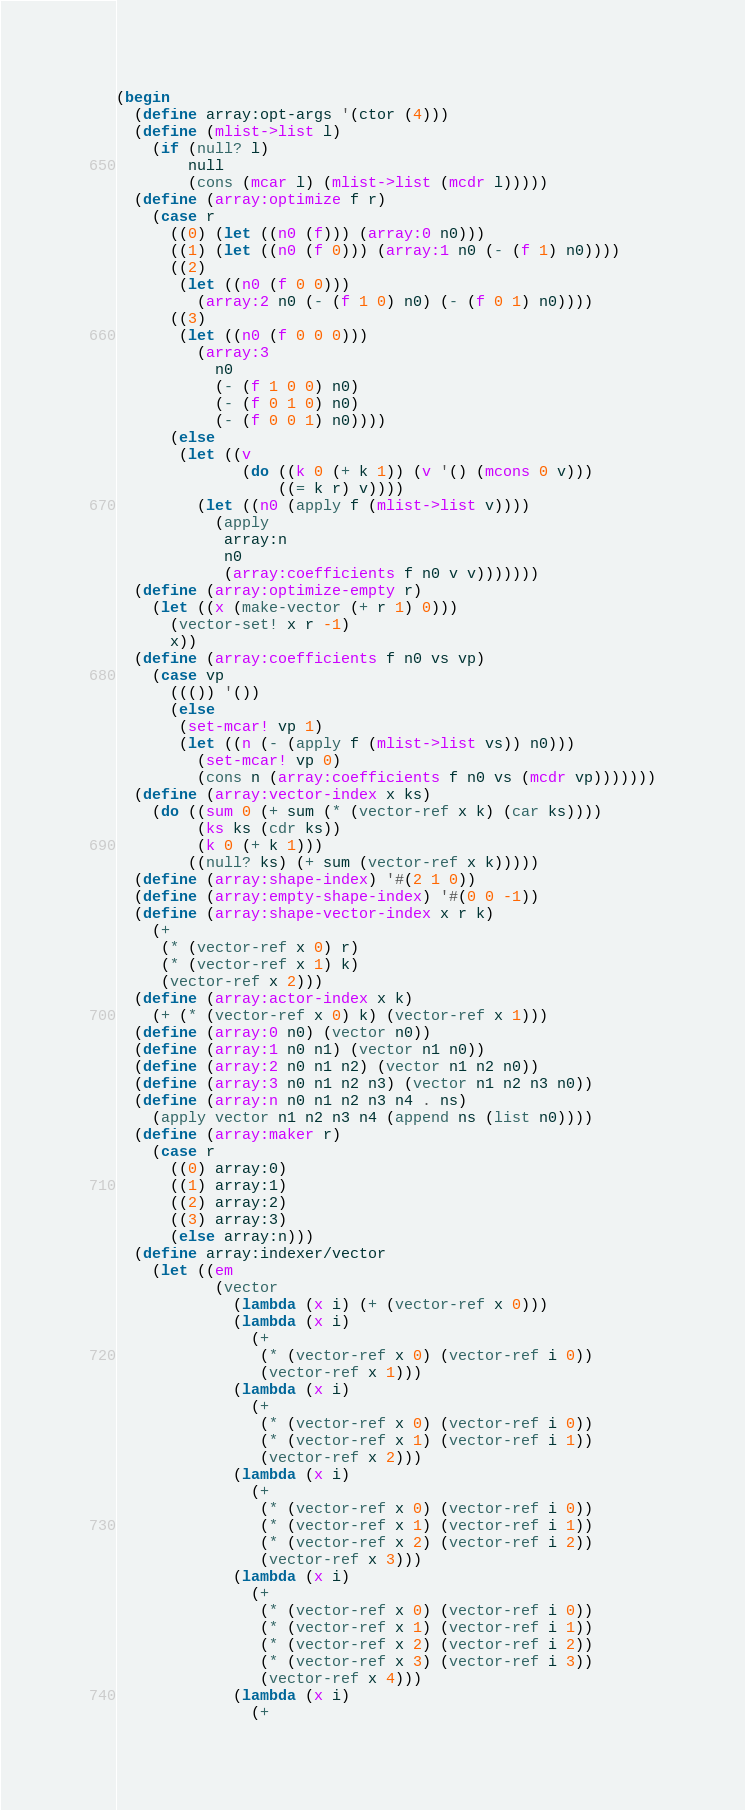<code> <loc_0><loc_0><loc_500><loc_500><_Scheme_>(begin
  (define array:opt-args '(ctor (4)))
  (define (mlist->list l)
    (if (null? l)
        null
        (cons (mcar l) (mlist->list (mcdr l)))))
  (define (array:optimize f r)
    (case r
      ((0) (let ((n0 (f))) (array:0 n0)))
      ((1) (let ((n0 (f 0))) (array:1 n0 (- (f 1) n0))))
      ((2)
       (let ((n0 (f 0 0)))
         (array:2 n0 (- (f 1 0) n0) (- (f 0 1) n0))))
      ((3)
       (let ((n0 (f 0 0 0)))
         (array:3
           n0
           (- (f 1 0 0) n0)
           (- (f 0 1 0) n0)
           (- (f 0 0 1) n0))))
      (else
       (let ((v
              (do ((k 0 (+ k 1)) (v '() (mcons 0 v)))
                  ((= k r) v))))
         (let ((n0 (apply f (mlist->list v))))
           (apply
            array:n
            n0
            (array:coefficients f n0 v v)))))))
  (define (array:optimize-empty r)
    (let ((x (make-vector (+ r 1) 0)))
      (vector-set! x r -1)
      x))
  (define (array:coefficients f n0 vs vp)
    (case vp
      ((()) '())
      (else
       (set-mcar! vp 1)
       (let ((n (- (apply f (mlist->list vs)) n0)))
         (set-mcar! vp 0)
         (cons n (array:coefficients f n0 vs (mcdr vp)))))))
  (define (array:vector-index x ks)
    (do ((sum 0 (+ sum (* (vector-ref x k) (car ks))))
         (ks ks (cdr ks))
         (k 0 (+ k 1)))
        ((null? ks) (+ sum (vector-ref x k)))))
  (define (array:shape-index) '#(2 1 0))
  (define (array:empty-shape-index) '#(0 0 -1))
  (define (array:shape-vector-index x r k)
    (+
     (* (vector-ref x 0) r)
     (* (vector-ref x 1) k)
     (vector-ref x 2)))
  (define (array:actor-index x k)
    (+ (* (vector-ref x 0) k) (vector-ref x 1)))
  (define (array:0 n0) (vector n0))
  (define (array:1 n0 n1) (vector n1 n0))
  (define (array:2 n0 n1 n2) (vector n1 n2 n0))
  (define (array:3 n0 n1 n2 n3) (vector n1 n2 n3 n0))
  (define (array:n n0 n1 n2 n3 n4 . ns)
    (apply vector n1 n2 n3 n4 (append ns (list n0))))
  (define (array:maker r)
    (case r
      ((0) array:0)
      ((1) array:1)
      ((2) array:2)
      ((3) array:3)
      (else array:n)))
  (define array:indexer/vector
    (let ((em
           (vector
             (lambda (x i) (+ (vector-ref x 0)))
             (lambda (x i)
               (+
                (* (vector-ref x 0) (vector-ref i 0))
                (vector-ref x 1)))
             (lambda (x i)
               (+
                (* (vector-ref x 0) (vector-ref i 0))
                (* (vector-ref x 1) (vector-ref i 1))
                (vector-ref x 2)))
             (lambda (x i)
               (+
                (* (vector-ref x 0) (vector-ref i 0))
                (* (vector-ref x 1) (vector-ref i 1))
                (* (vector-ref x 2) (vector-ref i 2))
                (vector-ref x 3)))
             (lambda (x i)
               (+
                (* (vector-ref x 0) (vector-ref i 0))
                (* (vector-ref x 1) (vector-ref i 1))
                (* (vector-ref x 2) (vector-ref i 2))
                (* (vector-ref x 3) (vector-ref i 3))
                (vector-ref x 4)))
             (lambda (x i)
               (+</code> 